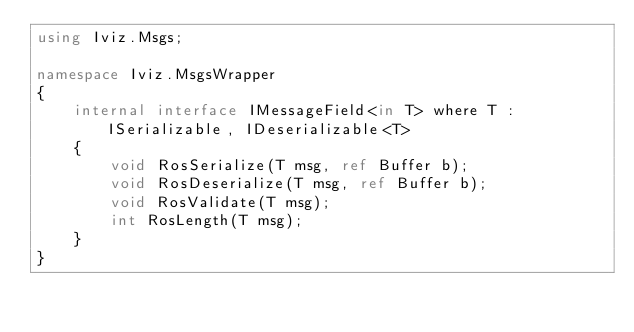<code> <loc_0><loc_0><loc_500><loc_500><_C#_>using Iviz.Msgs;

namespace Iviz.MsgsWrapper
{
    internal interface IMessageField<in T> where T : ISerializable, IDeserializable<T>
    {
        void RosSerialize(T msg, ref Buffer b);
        void RosDeserialize(T msg, ref Buffer b);
        void RosValidate(T msg);
        int RosLength(T msg);
    }
}</code> 